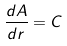<formula> <loc_0><loc_0><loc_500><loc_500>\frac { d A } { d r } = C</formula> 